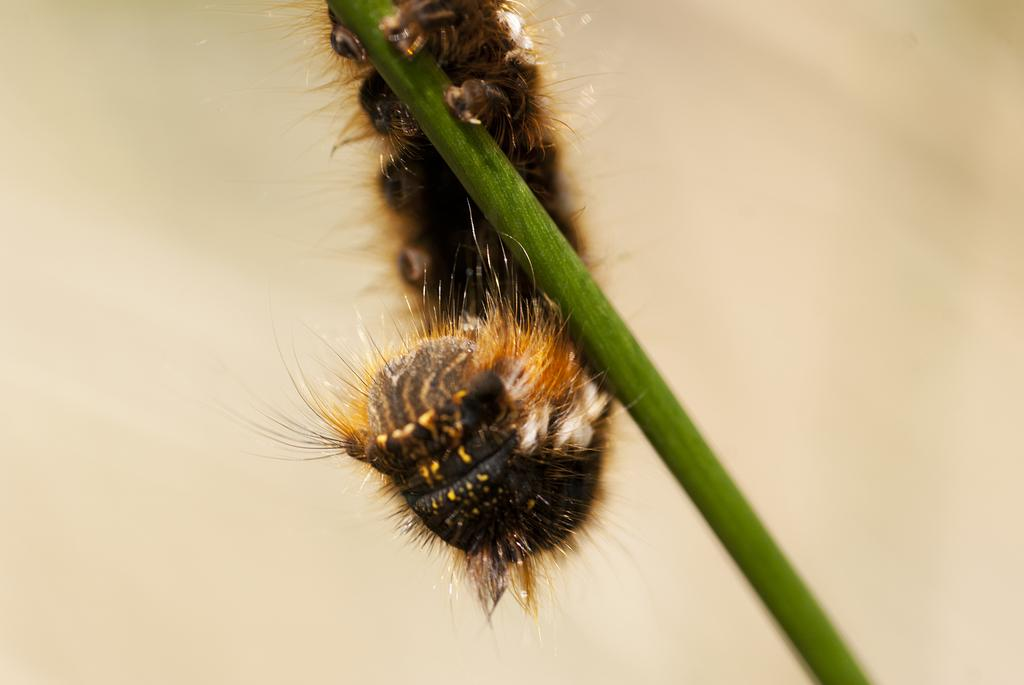What type of creature is in the image? There is an insect in the image. What is the insect sitting on? The insect is on a green color stick. Can you describe the background of the image? The background of the image is blurry. What type of camera is visible in the image? There is no camera present in the image; it features an insect on a green color stick with a blurry background. What type of structure is visible in the image? There is no structure visible in the image; it features an insect on a green color stick with a blurry background. 